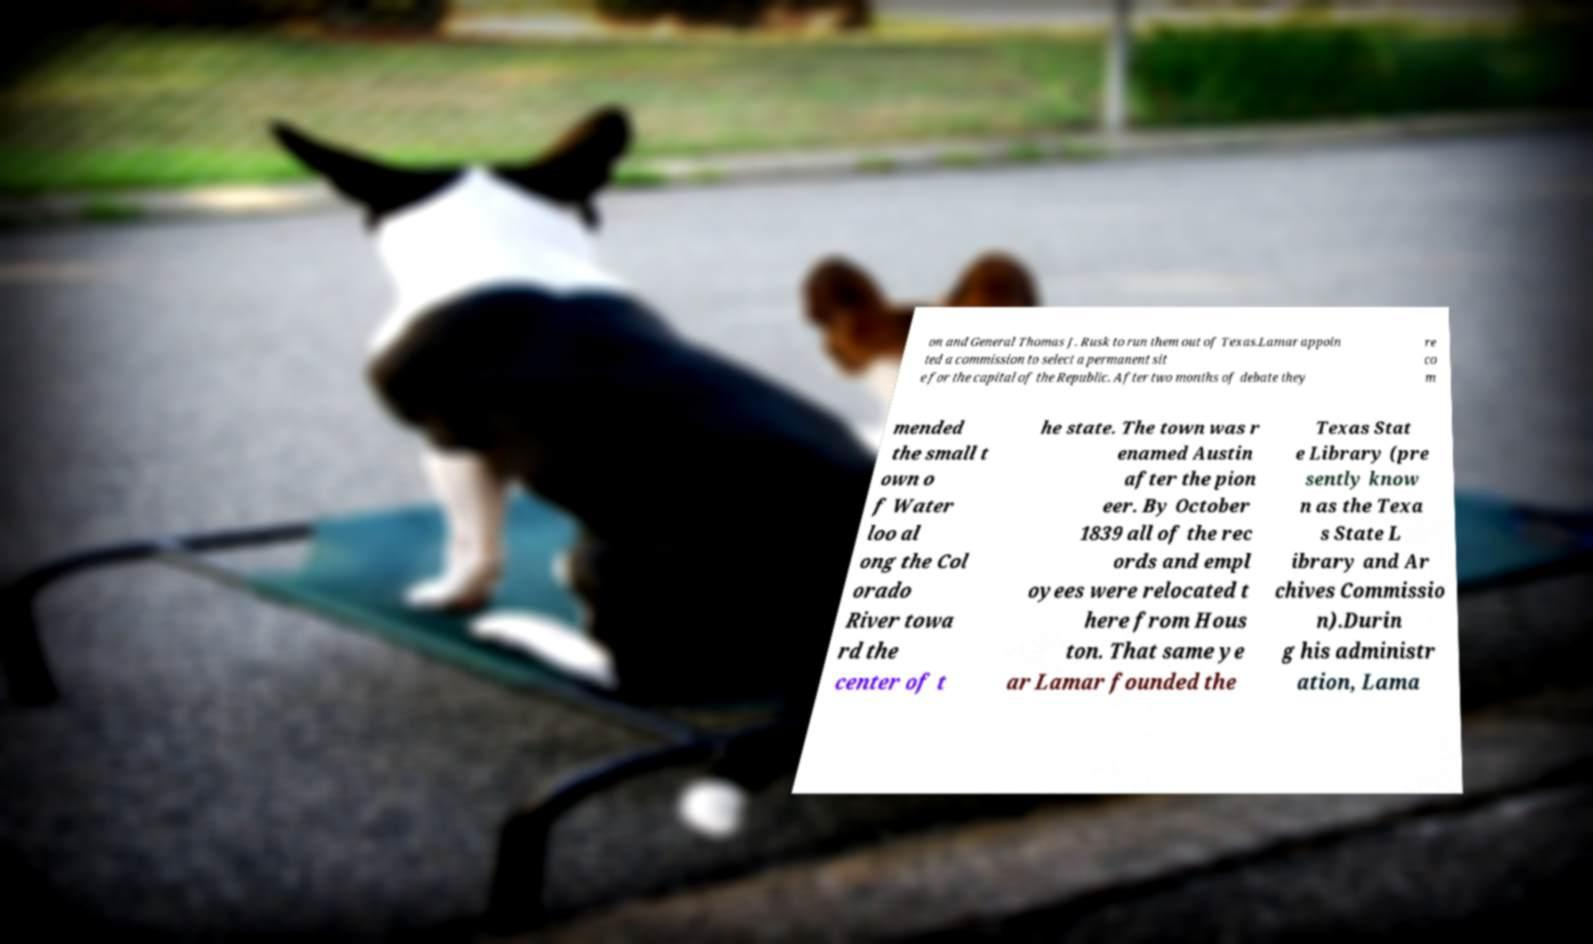Please read and relay the text visible in this image. What does it say? on and General Thomas J. Rusk to run them out of Texas.Lamar appoin ted a commission to select a permanent sit e for the capital of the Republic. After two months of debate they re co m mended the small t own o f Water loo al ong the Col orado River towa rd the center of t he state. The town was r enamed Austin after the pion eer. By October 1839 all of the rec ords and empl oyees were relocated t here from Hous ton. That same ye ar Lamar founded the Texas Stat e Library (pre sently know n as the Texa s State L ibrary and Ar chives Commissio n).Durin g his administr ation, Lama 